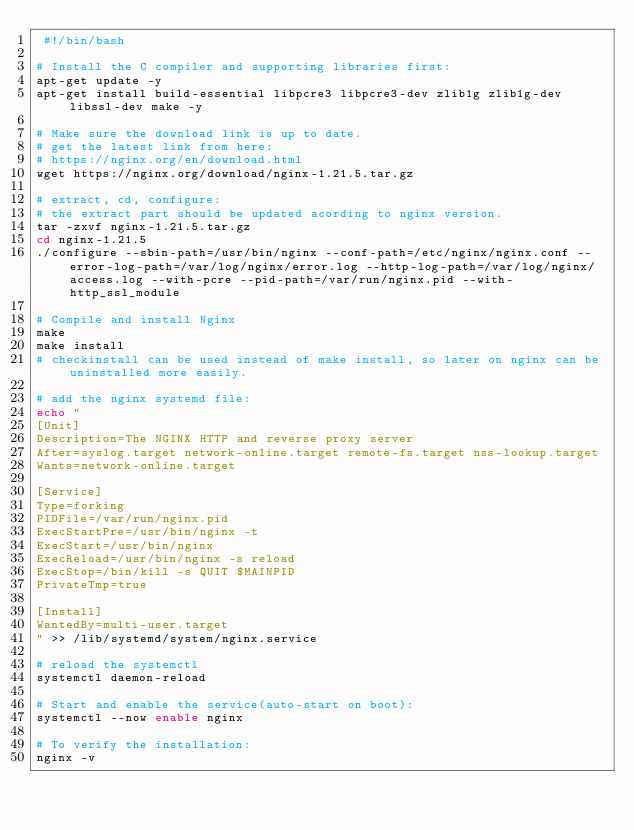<code> <loc_0><loc_0><loc_500><loc_500><_Bash_> #!/bin/bash

# Install the C compiler and supporting libraries first:
apt-get update -y
apt-get install build-essential libpcre3 libpcre3-dev zlib1g zlib1g-dev libssl-dev make -y

# Make sure the download link is up to date.
# get the latest link from here:
# https://nginx.org/en/download.html
wget https://nginx.org/download/nginx-1.21.5.tar.gz

# extract, cd, configure:
# the extract part should be updated acording to nginx version.
tar -zxvf nginx-1.21.5.tar.gz
cd nginx-1.21.5
./configure --sbin-path=/usr/bin/nginx --conf-path=/etc/nginx/nginx.conf --error-log-path=/var/log/nginx/error.log --http-log-path=/var/log/nginx/access.log --with-pcre --pid-path=/var/run/nginx.pid --with-http_ssl_module

# Compile and install Nginx
make
make install 
# checkinstall can be used instead of make install, so later on nginx can be uninstalled more easily.

# add the nginx systemd file:
echo "
[Unit]
Description=The NGINX HTTP and reverse proxy server
After=syslog.target network-online.target remote-fs.target nss-lookup.target
Wants=network-online.target

[Service]
Type=forking
PIDFile=/var/run/nginx.pid
ExecStartPre=/usr/bin/nginx -t
ExecStart=/usr/bin/nginx
ExecReload=/usr/bin/nginx -s reload
ExecStop=/bin/kill -s QUIT $MAINPID
PrivateTmp=true

[Install]
WantedBy=multi-user.target
" >> /lib/systemd/system/nginx.service

# reload the systemctl
systemctl daemon-reload

# Start and enable the service(auto-start on boot):
systemctl --now enable nginx

# To verify the installation:
nginx -v
</code> 